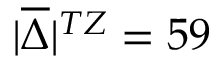<formula> <loc_0><loc_0><loc_500><loc_500>| \overline { \Delta } | ^ { T Z } = 5 9</formula> 